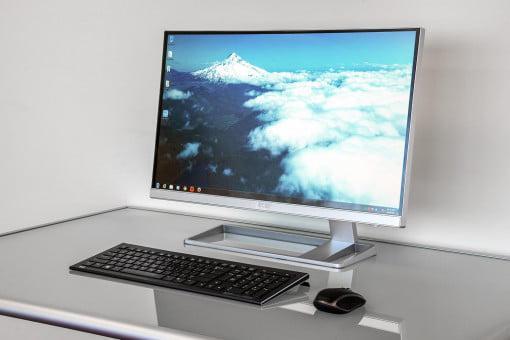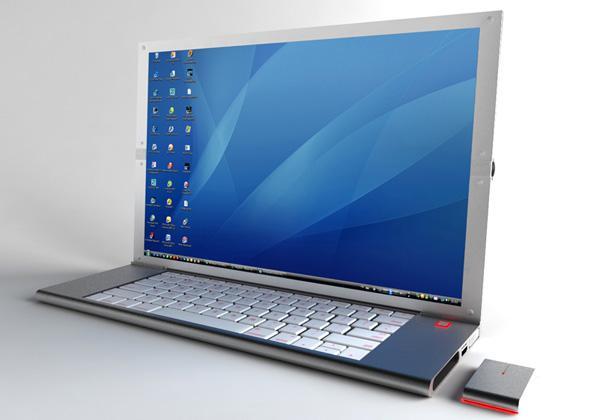The first image is the image on the left, the second image is the image on the right. Analyze the images presented: Is the assertion "The computer in the image on the left has a grey base." valid? Answer yes or no. Yes. The first image is the image on the left, the second image is the image on the right. Assess this claim about the two images: "The left image shows a screen elevated by a structure on at least one side above a keyboard.". Correct or not? Answer yes or no. Yes. 